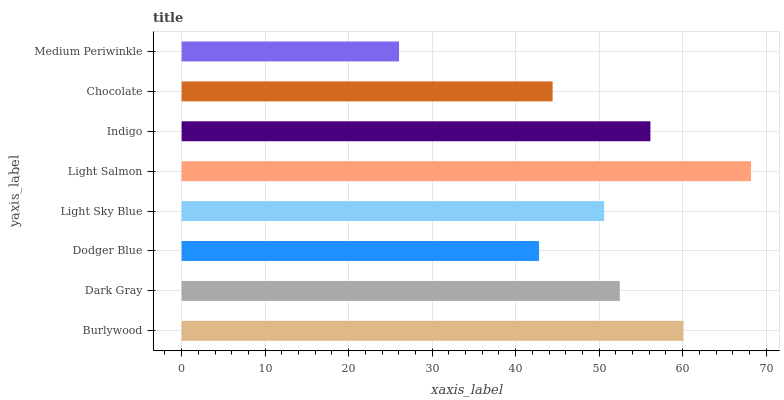Is Medium Periwinkle the minimum?
Answer yes or no. Yes. Is Light Salmon the maximum?
Answer yes or no. Yes. Is Dark Gray the minimum?
Answer yes or no. No. Is Dark Gray the maximum?
Answer yes or no. No. Is Burlywood greater than Dark Gray?
Answer yes or no. Yes. Is Dark Gray less than Burlywood?
Answer yes or no. Yes. Is Dark Gray greater than Burlywood?
Answer yes or no. No. Is Burlywood less than Dark Gray?
Answer yes or no. No. Is Dark Gray the high median?
Answer yes or no. Yes. Is Light Sky Blue the low median?
Answer yes or no. Yes. Is Burlywood the high median?
Answer yes or no. No. Is Chocolate the low median?
Answer yes or no. No. 